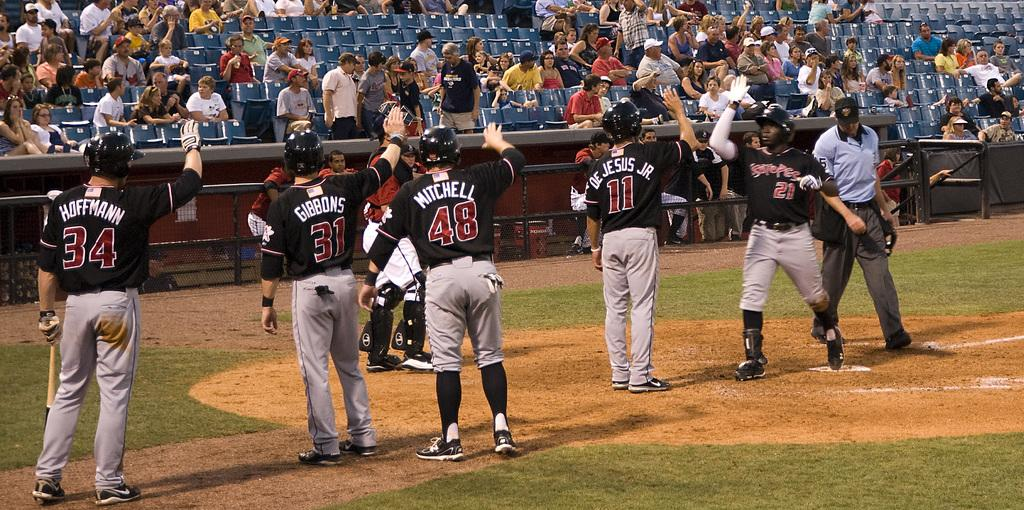Provide a one-sentence caption for the provided image. Hoffman will be the last player that number 21 high fives. 